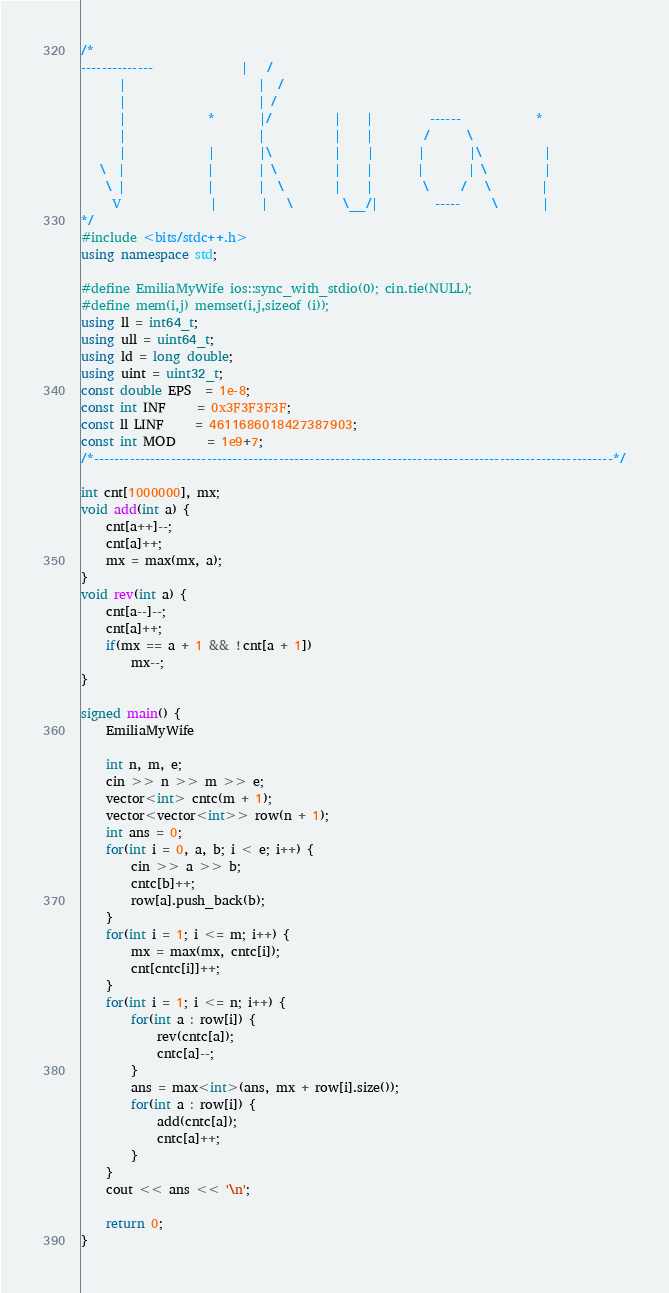Convert code to text. <code><loc_0><loc_0><loc_500><loc_500><_C++_>/*
--------------              |   /
      |                     |  /
      |                     | /
      |             *       |/          |    |         ------            *
      |                     |           |    |        /      \
      |             |       |\          |    |       |       |\          |
   \  |             |       | \         |    |       |       | \         |
    \ |             |       |  \        |    |        \     /   \        |
     V              |       |   \        \__/|         -----     \       |
*/
#include <bits/stdc++.h>
using namespace std;

#define EmiliaMyWife ios::sync_with_stdio(0); cin.tie(NULL);
#define mem(i,j) memset(i,j,sizeof (i));
using ll = int64_t;
using ull = uint64_t;
using ld = long double;
using uint = uint32_t;
const double EPS  = 1e-8;
const int INF     = 0x3F3F3F3F;
const ll LINF     = 4611686018427387903;
const int MOD     = 1e9+7;
/*-----------------------------------------------------------------------------------------------------*/

int cnt[1000000], mx;
void add(int a) {
	cnt[a++]--;
	cnt[a]++;
	mx = max(mx, a);
}
void rev(int a) {
	cnt[a--]--;
	cnt[a]++;
	if(mx == a + 1 && !cnt[a + 1])
		mx--;
}

signed main() {
	EmiliaMyWife

	int n, m, e;
	cin >> n >> m >> e;
	vector<int> cntc(m + 1);
	vector<vector<int>> row(n + 1);
	int ans = 0;
	for(int i = 0, a, b; i < e; i++) {
		cin >> a >> b;
		cntc[b]++;
		row[a].push_back(b);
	}
	for(int i = 1; i <= m; i++) {
		mx = max(mx, cntc[i]);
		cnt[cntc[i]]++;
	}
	for(int i = 1; i <= n; i++) {
		for(int a : row[i]) {
			rev(cntc[a]);
			cntc[a]--;
		}
		ans = max<int>(ans, mx + row[i].size());
		for(int a : row[i]) {
			add(cntc[a]);
			cntc[a]++;
		}
	}
	cout << ans << '\n';
			
	return 0;
}
</code> 